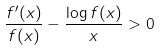<formula> <loc_0><loc_0><loc_500><loc_500>\frac { f ^ { \prime } ( x ) } { f ( x ) } - \frac { \log { f ( x ) } } { x } > 0</formula> 